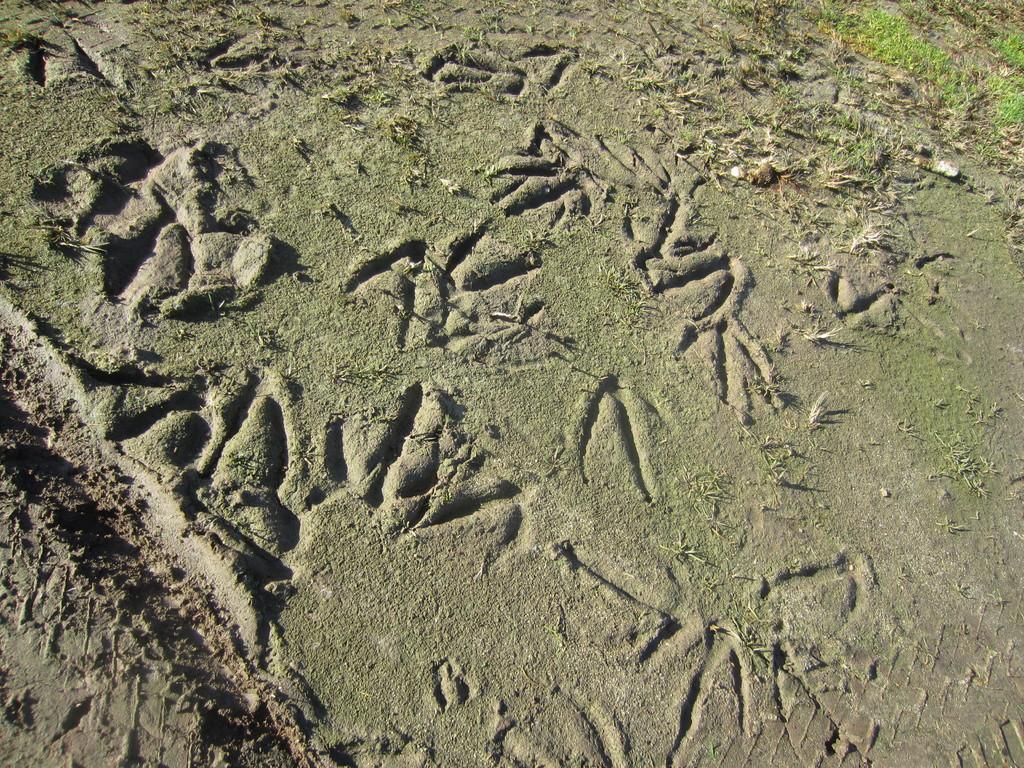Can you describe this image briefly? This picture is consists of sand floor. 